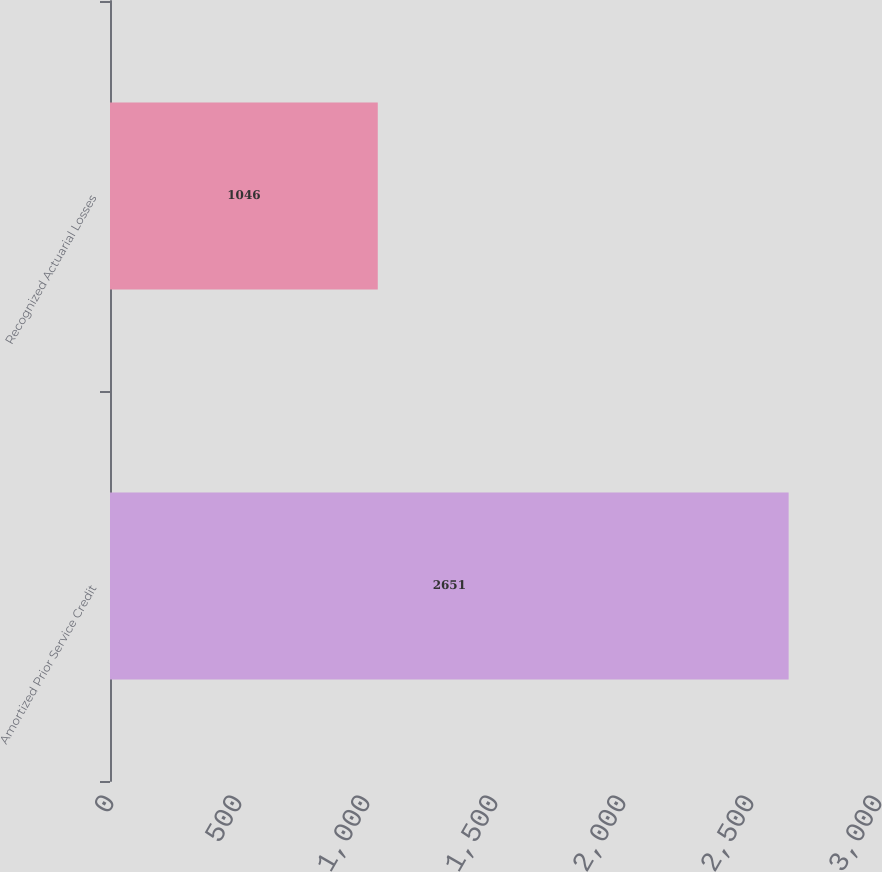<chart> <loc_0><loc_0><loc_500><loc_500><bar_chart><fcel>Amortized Prior Service Credit<fcel>Recognized Actuarial Losses<nl><fcel>2651<fcel>1046<nl></chart> 